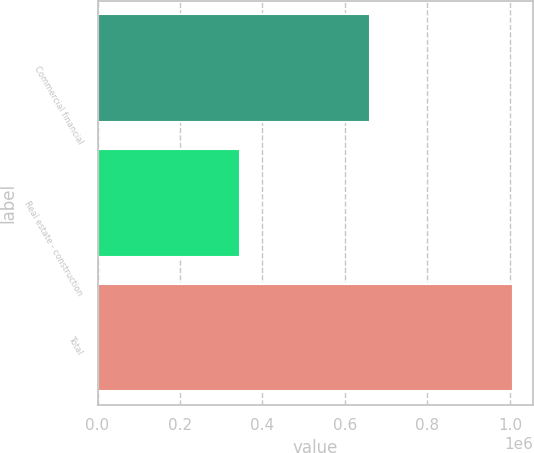Convert chart. <chart><loc_0><loc_0><loc_500><loc_500><bar_chart><fcel>Commercial financial<fcel>Real estate - construction<fcel>Total<nl><fcel>660346<fcel>346201<fcel>1.00655e+06<nl></chart> 